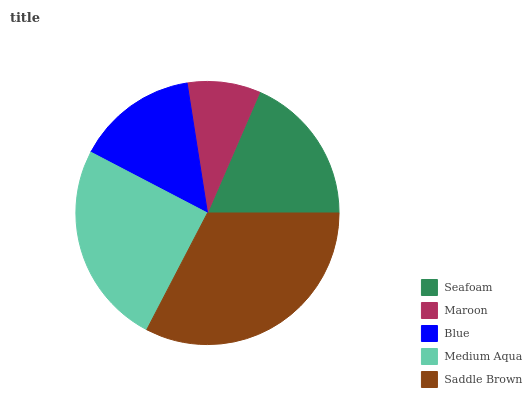Is Maroon the minimum?
Answer yes or no. Yes. Is Saddle Brown the maximum?
Answer yes or no. Yes. Is Blue the minimum?
Answer yes or no. No. Is Blue the maximum?
Answer yes or no. No. Is Blue greater than Maroon?
Answer yes or no. Yes. Is Maroon less than Blue?
Answer yes or no. Yes. Is Maroon greater than Blue?
Answer yes or no. No. Is Blue less than Maroon?
Answer yes or no. No. Is Seafoam the high median?
Answer yes or no. Yes. Is Seafoam the low median?
Answer yes or no. Yes. Is Medium Aqua the high median?
Answer yes or no. No. Is Saddle Brown the low median?
Answer yes or no. No. 